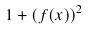Convert formula to latex. <formula><loc_0><loc_0><loc_500><loc_500>1 + ( f ( x ) ) ^ { 2 }</formula> 